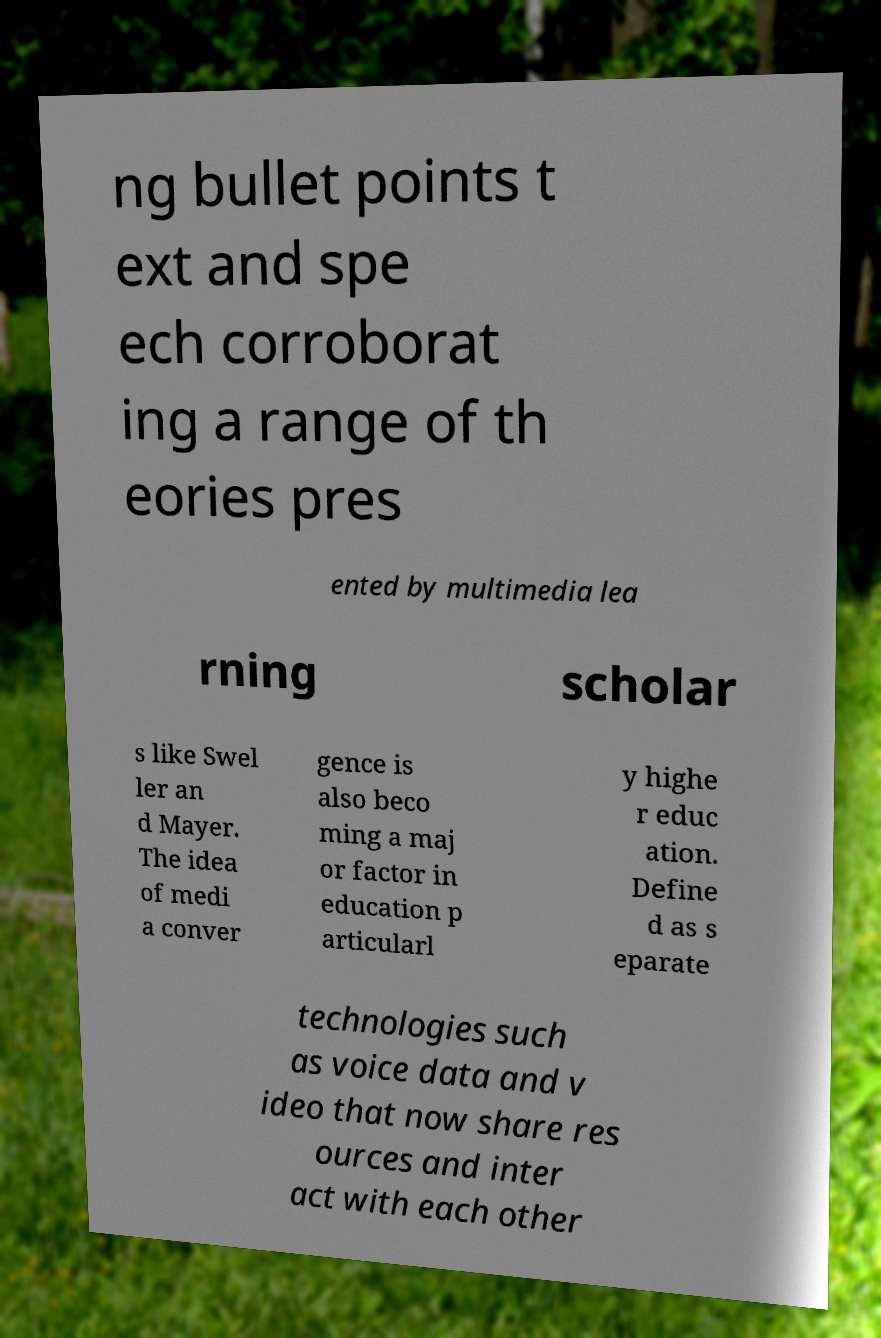Could you extract and type out the text from this image? ng bullet points t ext and spe ech corroborat ing a range of th eories pres ented by multimedia lea rning scholar s like Swel ler an d Mayer. The idea of medi a conver gence is also beco ming a maj or factor in education p articularl y highe r educ ation. Define d as s eparate technologies such as voice data and v ideo that now share res ources and inter act with each other 